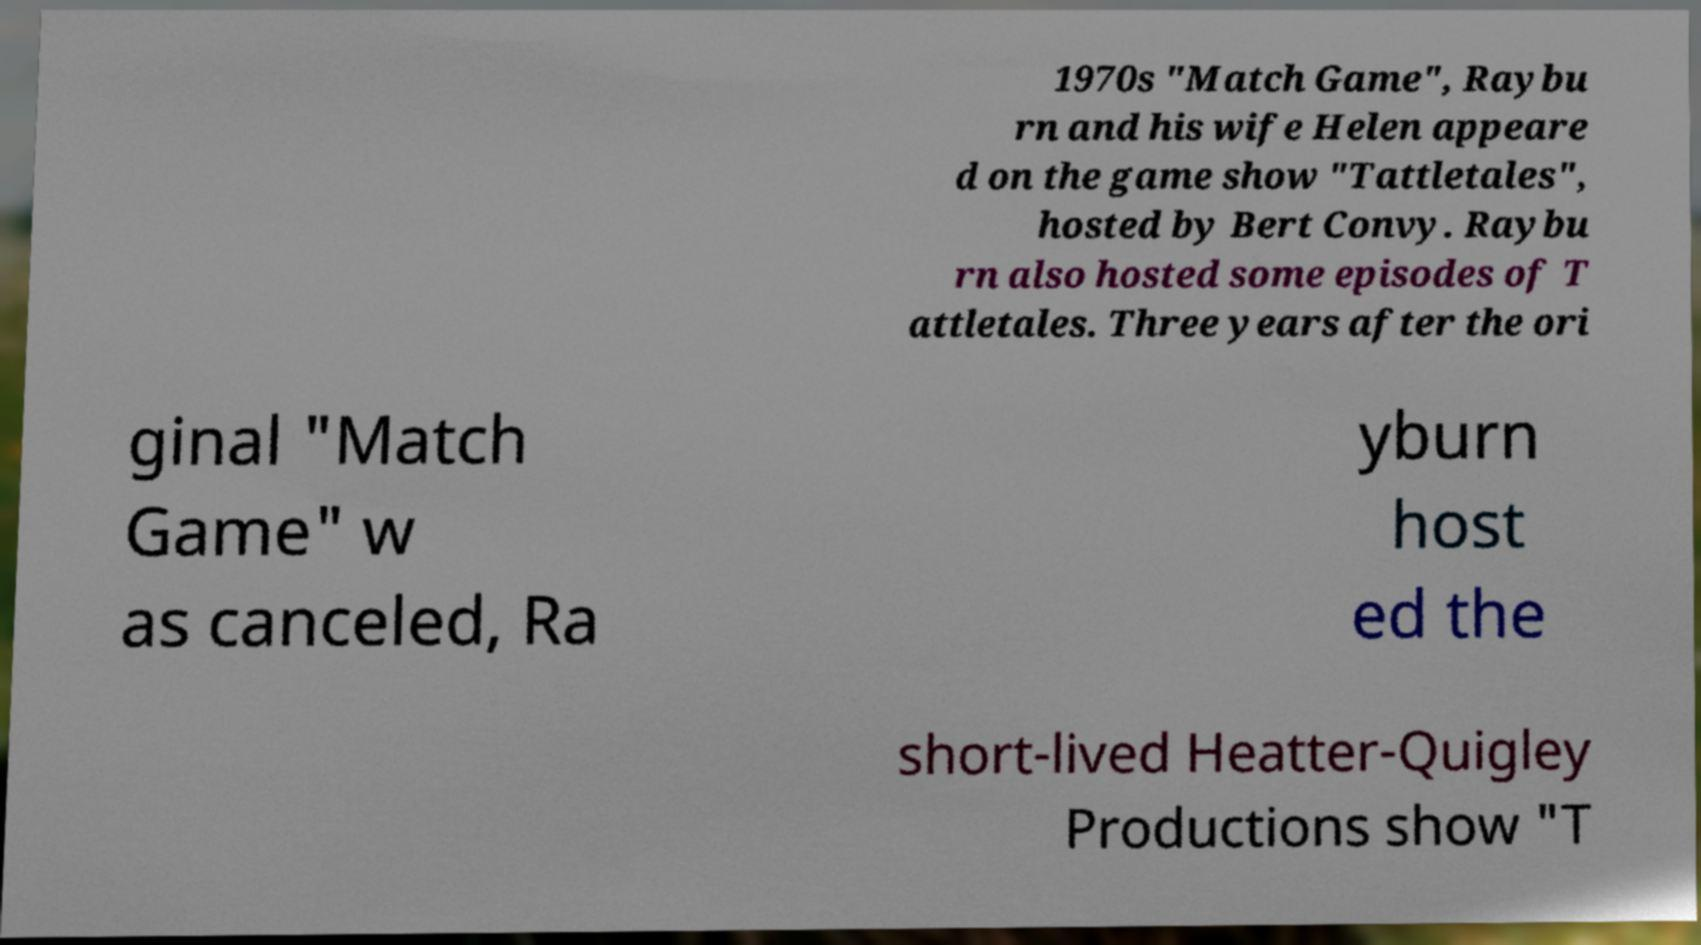Can you read and provide the text displayed in the image?This photo seems to have some interesting text. Can you extract and type it out for me? 1970s "Match Game", Raybu rn and his wife Helen appeare d on the game show "Tattletales", hosted by Bert Convy. Raybu rn also hosted some episodes of T attletales. Three years after the ori ginal "Match Game" w as canceled, Ra yburn host ed the short-lived Heatter-Quigley Productions show "T 